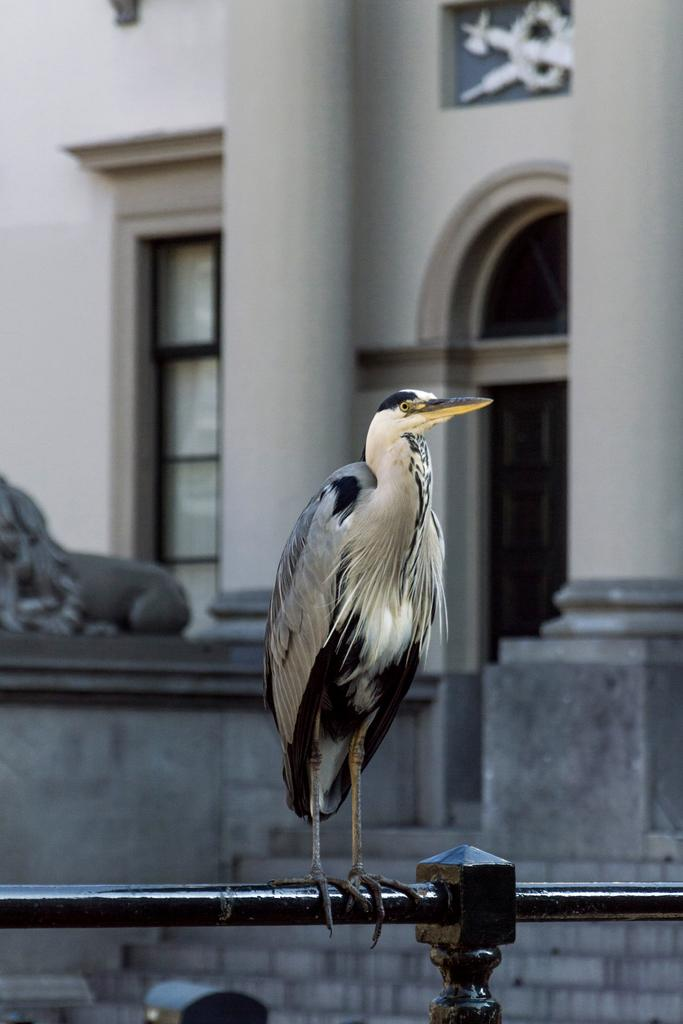What type of animal is in the image? There is a bird in the image. What is the bird standing on? The bird is standing on a rod. What can be seen in the background of the image? There are pillars and a wall in the background of the image. How many sticks are being held by the bird in the image? There are no sticks present in the image; the bird is standing on a rod. What type of flower is being held by the bird in the image? There is no flower, such as a rose, present in the image; the bird is standing on a rod. 